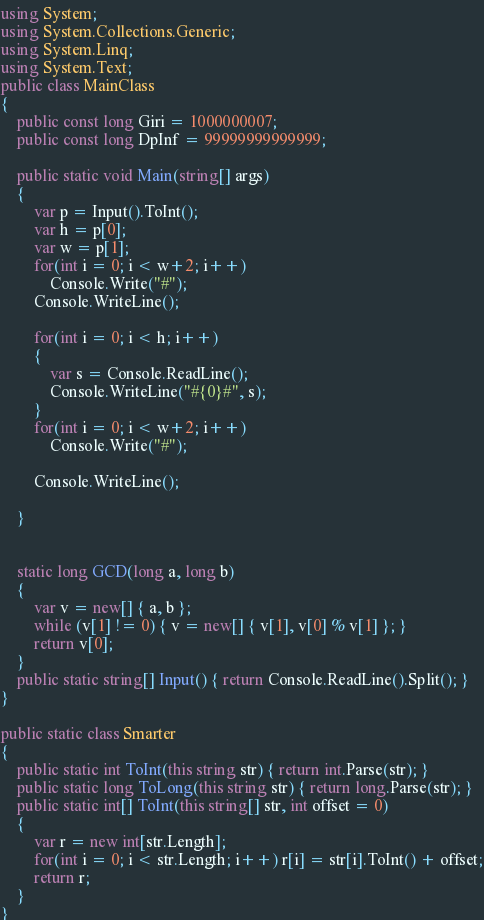<code> <loc_0><loc_0><loc_500><loc_500><_C#_>using System;
using System.Collections.Generic;
using System.Linq;
using System.Text;
public class MainClass
{
	public const long Giri = 1000000007;
	public const long DpInf = 99999999999999;
	
	public static void Main(string[] args)
	{
		var p = Input().ToInt();
		var h = p[0]; 
		var w = p[1]; 
		for(int i = 0; i < w+2; i++)
			Console.Write("#");
		Console.WriteLine();
			
		for(int i = 0; i < h; i++)
		{
			var s = Console.ReadLine();
			Console.WriteLine("#{0}#", s);
		}
		for(int i = 0; i < w+2; i++)
			Console.Write("#");
		
		Console.WriteLine();

	}

	
	static long GCD(long a, long b)
	{
		var v = new[] { a, b };
		while (v[1] != 0) { v = new[] { v[1], v[0] % v[1] }; }
		return v[0];
	}
	public static string[] Input() { return Console.ReadLine().Split(); }
}

public static class Smarter
{
	public static int ToInt(this string str) { return int.Parse(str); }
	public static long ToLong(this string str) { return long.Parse(str); }
	public static int[] ToInt(this string[] str, int offset = 0)
	{
		var r = new int[str.Length];
		for(int i = 0; i < str.Length; i++) r[i] = str[i].ToInt() + offset;
		return r;
	}
}</code> 